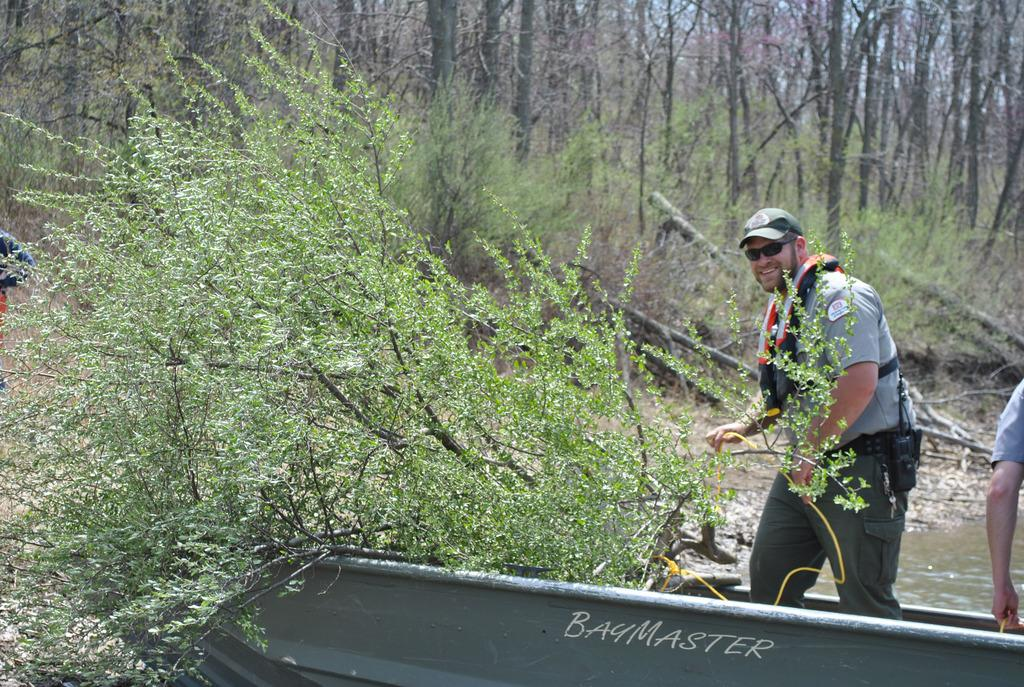<image>
Relay a brief, clear account of the picture shown. Two men are in a boat, called the Bay Master. 